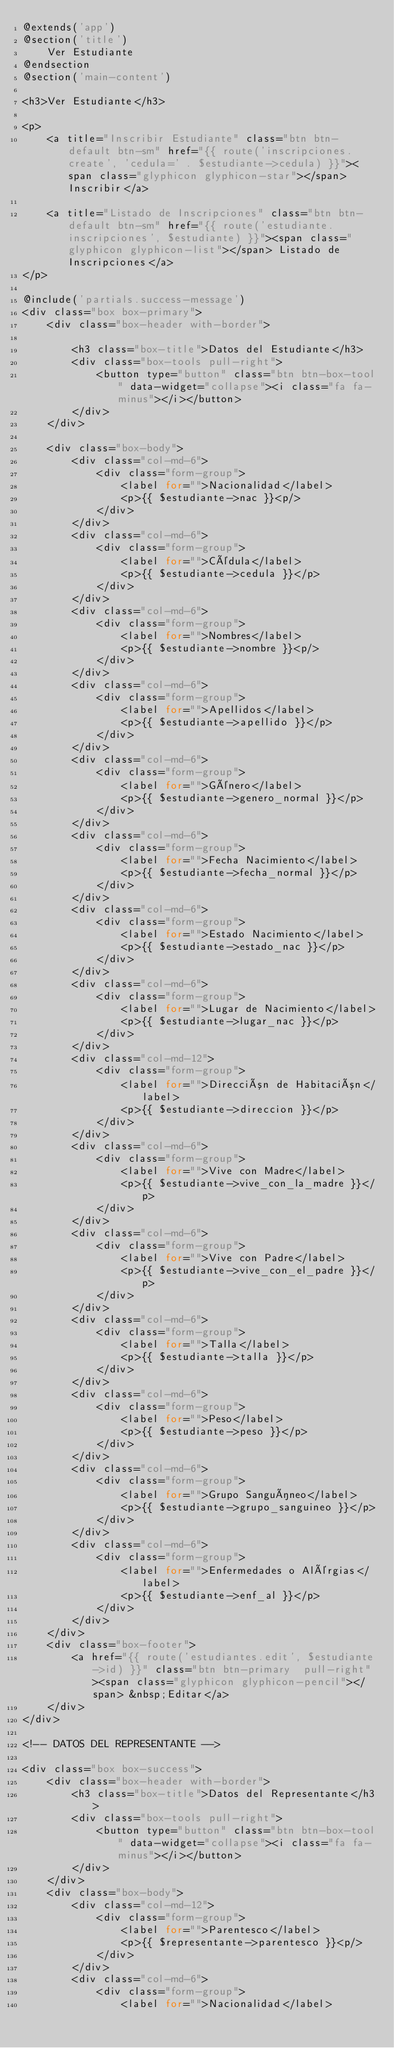<code> <loc_0><loc_0><loc_500><loc_500><_PHP_>@extends('app')
@section('title')
	Ver Estudiante
@endsection
@section('main-content')

<h3>Ver Estudiante</h3>

<p>
	<a title="Inscribir Estudiante" class="btn btn-default btn-sm" href="{{ route('inscripciones.create', 'cedula=' . $estudiante->cedula) }}"><span class="glyphicon glyphicon-star"></span> Inscribir</a>

	<a title="Listado de Inscripciones" class="btn btn-default btn-sm" href="{{ route('estudiante.inscripciones', $estudiante) }}"><span class="glyphicon glyphicon-list"></span> Listado de Inscripciones</a>
</p>

@include('partials.success-message')
<div class="box box-primary">
	<div class="box-header with-border">
			
		<h3 class="box-title">Datos del Estudiante</h3>
		<div class="box-tools pull-right">
			<button type="button" class="btn btn-box-tool" data-widget="collapse"><i class="fa fa-minus"></i></button>
		</div>
	</div>

	<div class="box-body">
		<div class="col-md-6">
			<div class="form-group">
				<label for="">Nacionalidad</label>
				<p>{{ $estudiante->nac }}<p/>
			</div>
		</div>
		<div class="col-md-6">
			<div class="form-group">
				<label for="">Cédula</label>
				<p>{{ $estudiante->cedula }}</p>
			</div>
		</div>
		<div class="col-md-6">
			<div class="form-group">
				<label for="">Nombres</label>
				<p>{{ $estudiante->nombre }}<p/>
			</div>
		</div>
		<div class="col-md-6">
			<div class="form-group">
				<label for="">Apellidos</label>
				<p>{{ $estudiante->apellido }}</p>
			</div>
		</div>
		<div class="col-md-6">
			<div class="form-group">
				<label for="">Género</label>
				<p>{{ $estudiante->genero_normal }}</p>
			</div>
		</div>
		<div class="col-md-6">
			<div class="form-group">
				<label for="">Fecha Nacimiento</label>
				<p>{{ $estudiante->fecha_normal }}</p>
			</div>
		</div>
		<div class="col-md-6">
			<div class="form-group">
				<label for="">Estado Nacimiento</label>
				<p>{{ $estudiante->estado_nac }}</p>
			</div>
		</div>
		<div class="col-md-6">
			<div class="form-group">
				<label for="">Lugar de Nacimiento</label>
				<p>{{ $estudiante->lugar_nac }}</p>
			</div>
		</div>
		<div class="col-md-12">
			<div class="form-group">
				<label for="">Dirección de Habitación</label>
				<p>{{ $estudiante->direccion }}</p>
			</div>
		</div>
		<div class="col-md-6">
			<div class="form-group">
				<label for="">Vive con Madre</label>
				<p>{{ $estudiante->vive_con_la_madre }}</p>
			</div>
		</div>
		<div class="col-md-6">
			<div class="form-group">
				<label for="">Vive con Padre</label>
				<p>{{ $estudiante->vive_con_el_padre }}</p>
			</div>
		</div>
		<div class="col-md-6">
			<div class="form-group">
				<label for="">Talla</label>
				<p>{{ $estudiante->talla }}</p>
			</div>
		</div>
		<div class="col-md-6">
			<div class="form-group">
				<label for="">Peso</label>
				<p>{{ $estudiante->peso }}</p>
			</div>
		</div>
		<div class="col-md-6">
			<div class="form-group">
				<label for="">Grupo Sanguíneo</label>
				<p>{{ $estudiante->grupo_sanguineo }}</p>
			</div>
		</div>
		<div class="col-md-6">
			<div class="form-group">
				<label for="">Enfermedades o Alérgias</label>
				<p>{{ $estudiante->enf_al }}</p>
			</div>
		</div>
	</div>
	<div class="box-footer">
		<a href="{{ route('estudiantes.edit', $estudiante->id) }}" class="btn btn-primary  pull-right"><span class="glyphicon glyphicon-pencil"></span> &nbsp;Editar</a>
	</div>
</div>

<!-- DATOS DEL REPRESENTANTE -->

<div class="box box-success">
	<div class="box-header with-border">
		<h3 class="box-title">Datos del Representante</h3>
		<div class="box-tools pull-right">
			<button type="button" class="btn btn-box-tool" data-widget="collapse"><i class="fa fa-minus"></i></button>
		</div>
	</div>
	<div class="box-body">
		<div class="col-md-12">
			<div class="form-group">
				<label for="">Parentesco</label>
				<p>{{ $representante->parentesco }}<p/>
			</div>
		</div>
		<div class="col-md-6">
			<div class="form-group">
				<label for="">Nacionalidad</label></code> 